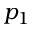<formula> <loc_0><loc_0><loc_500><loc_500>p _ { 1 }</formula> 